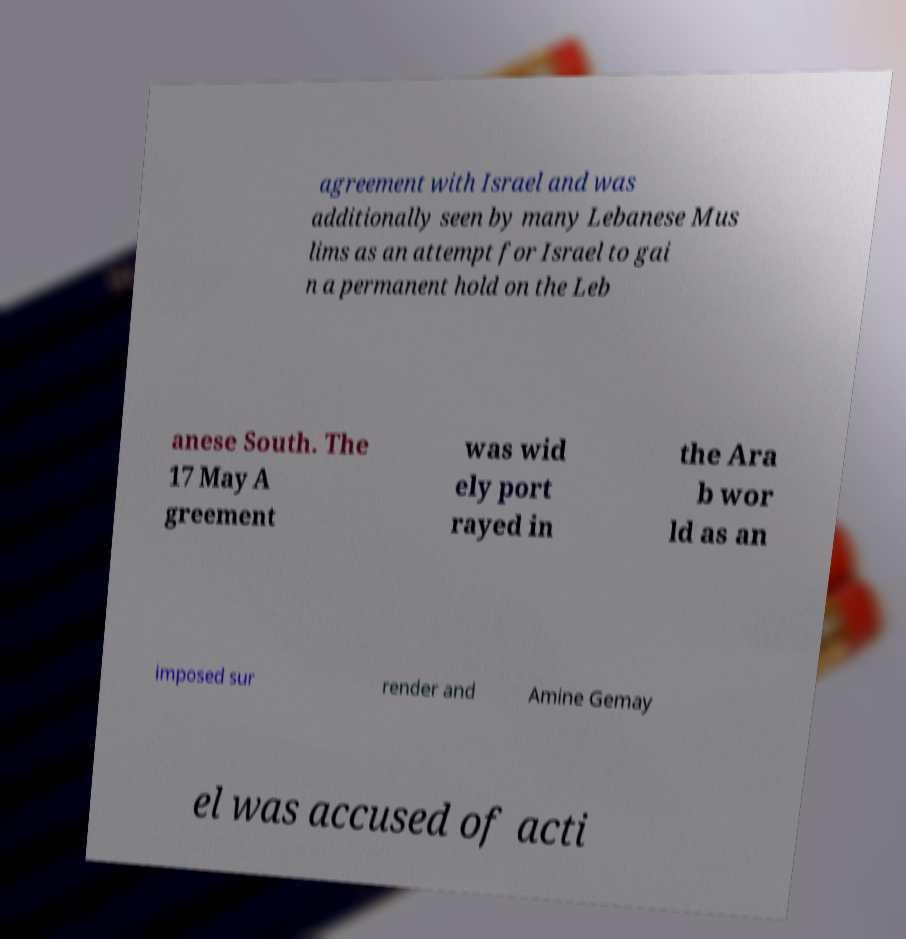Can you read and provide the text displayed in the image?This photo seems to have some interesting text. Can you extract and type it out for me? agreement with Israel and was additionally seen by many Lebanese Mus lims as an attempt for Israel to gai n a permanent hold on the Leb anese South. The 17 May A greement was wid ely port rayed in the Ara b wor ld as an imposed sur render and Amine Gemay el was accused of acti 